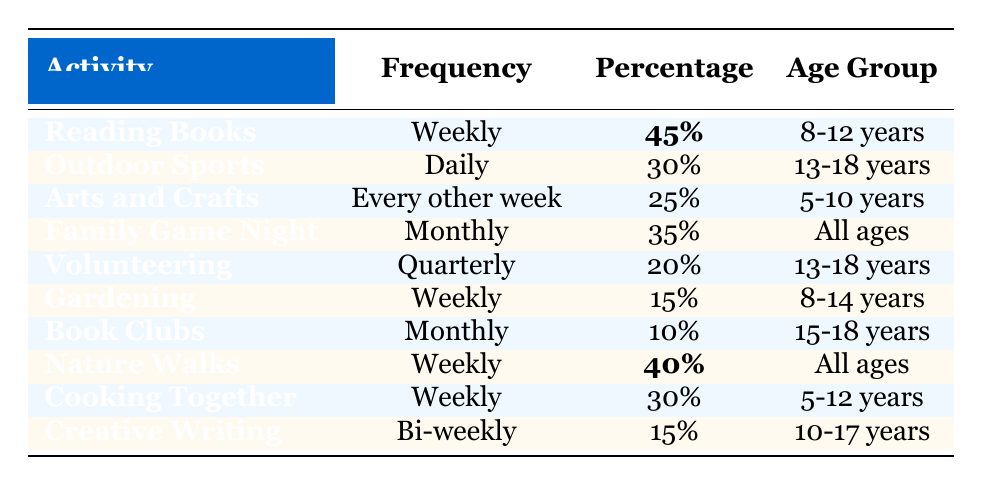What is the most frequent screen-free activity among students aged 8-12 years? The table shows that "Reading Books" is the only activity listed for the 8-12 age group, with a frequency of "Weekly" and a percentage of 45%. Therefore, it is the most frequent activity for this age group.
Answer: Reading Books What percentage of students engage in Outdoor Sports daily? The table indicates that 30% of students aged 13-18 years participate in Outdoor Sports daily.
Answer: 30% How often do students participate in Family Game Night? According to the table, Family Game Night occurs monthly across all age groups.
Answer: Monthly What is the average percentage of students participating in weekly activities among the presented activities? The activities that occur weekly are "Reading Books" (45%), "Gardening" (15%), "Nature Walks" (40%), and "Cooking Together" (30%). The sum of these percentages is 130%, and there are 4 activities, so the average is 130% / 4 = 32.5%.
Answer: 32.5% Is the percentage of students participating in Volunteering greater than 15%? The table states that 20% of students aged 13-18 years volunteer quarterly, which is greater than 15%.
Answer: Yes Which screen-free activity has the highest percentage of participation among students across all age groups? The highest percentage is found in "Reading Books" at 45%. No other activity surpasses this percentage in any age group mentioned.
Answer: Reading Books How many screen-free activities listed have a frequency of "Weekly"? From the table, the activities listed with a "Weekly" frequency are "Reading Books," "Gardening," "Nature Walks," and "Cooking Together," totaling 4 activities.
Answer: 4 What percentage of students participate in Book Clubs at a monthly frequency? The table indicates that 10% of students aged 15-18 years participate in Book Clubs monthly.
Answer: 10% If we combine the percentages of students participating in Weekly Nature Walks and Cooking Together, what is the result? The percentage for Nature Walks is 40% and for Cooking Together is 30%. Adding these together results in 40% + 30% = 70%.
Answer: 70% Are Family Game Night and Cooking Together equally popular among the age groups considered? Family Game Night has a percentage of 35% while Cooking Together has a percentage of 30%. They are not equally popular as Family Game Night has a higher percentage.
Answer: No 